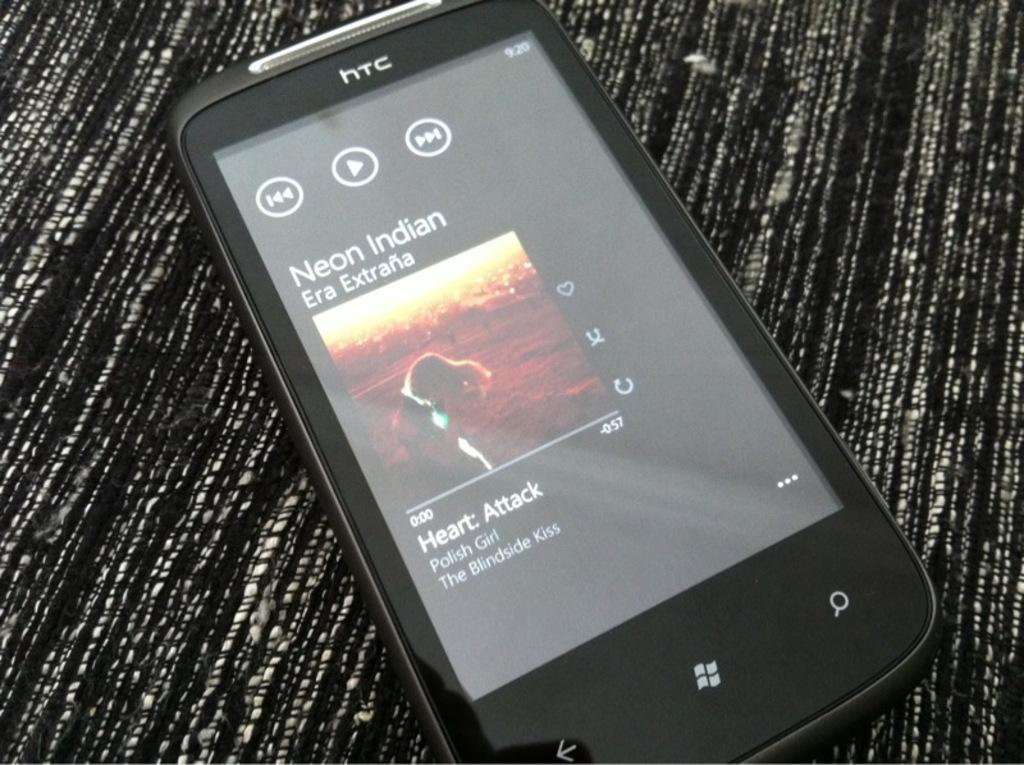<image>
Write a terse but informative summary of the picture. The black phone shown is about to play the song Heart Attack. 